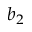<formula> <loc_0><loc_0><loc_500><loc_500>b _ { 2 }</formula> 